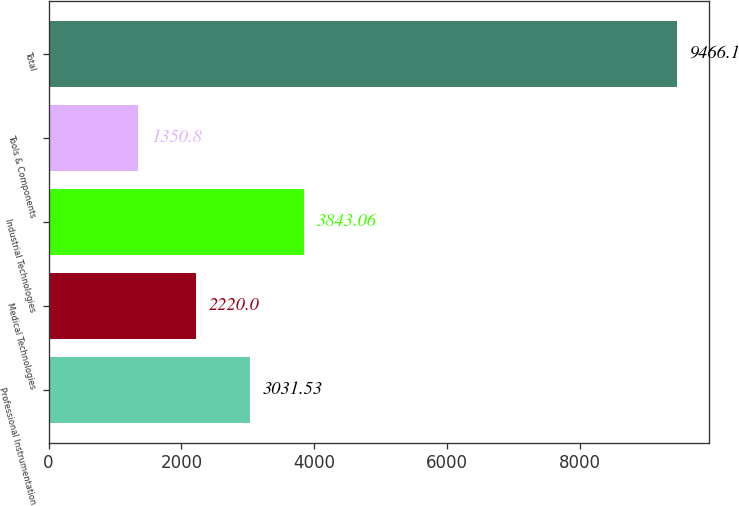Convert chart to OTSL. <chart><loc_0><loc_0><loc_500><loc_500><bar_chart><fcel>Professional Instrumentation<fcel>Medical Technologies<fcel>Industrial Technologies<fcel>Tools & Components<fcel>Total<nl><fcel>3031.53<fcel>2220<fcel>3843.06<fcel>1350.8<fcel>9466.1<nl></chart> 